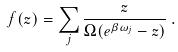Convert formula to latex. <formula><loc_0><loc_0><loc_500><loc_500>f ( z ) = \sum _ { j } \frac { z } { \Omega ( e ^ { \beta \omega _ { j } } - z ) } \, .</formula> 